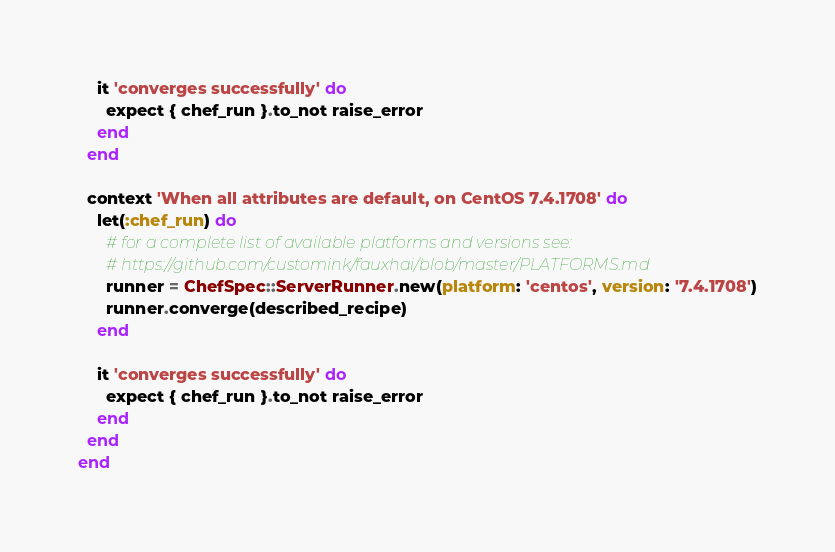Convert code to text. <code><loc_0><loc_0><loc_500><loc_500><_Ruby_>    it 'converges successfully' do
      expect { chef_run }.to_not raise_error
    end
  end

  context 'When all attributes are default, on CentOS 7.4.1708' do
    let(:chef_run) do
      # for a complete list of available platforms and versions see:
      # https://github.com/customink/fauxhai/blob/master/PLATFORMS.md
      runner = ChefSpec::ServerRunner.new(platform: 'centos', version: '7.4.1708')
      runner.converge(described_recipe)
    end

    it 'converges successfully' do
      expect { chef_run }.to_not raise_error
    end
  end
end
</code> 